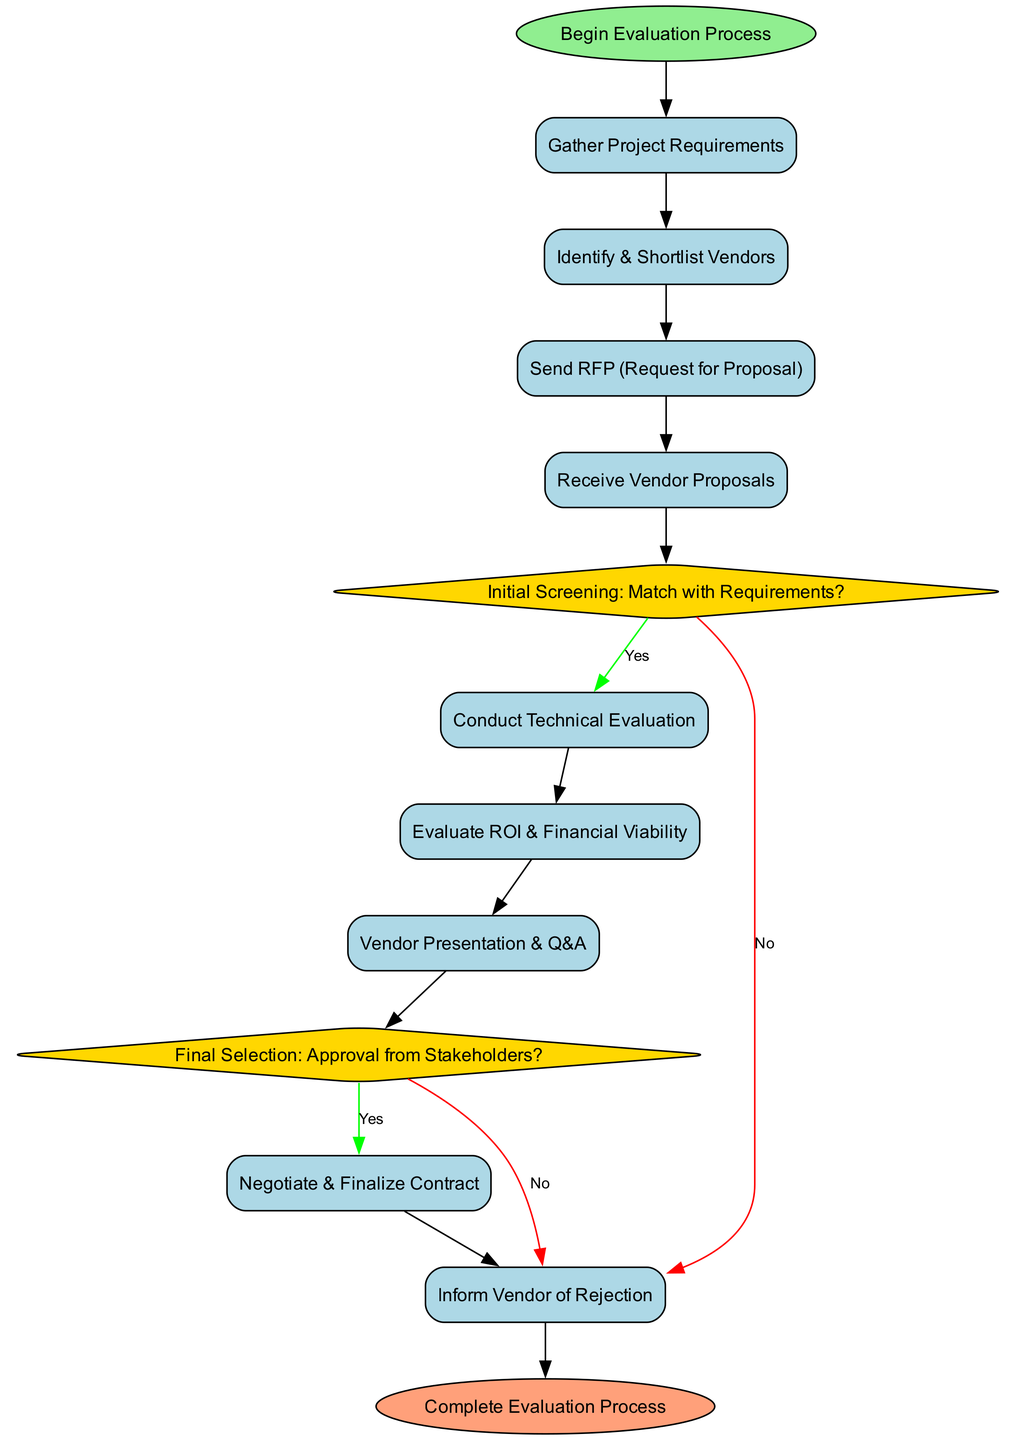What is the first step in the evaluation process? The diagram shows that the first node is labeled "Begin Evaluation Process," indicating that this is the initial step in the workflow.
Answer: Begin Evaluation Process How many decision points are present in the diagram? The diagram contains two decision nodes: "Initial Screening: Match with Requirements?" and "Final Selection: Approval from Stakeholders?" Therefore, there are two decision points.
Answer: 2 What follows after receiving vendor proposals? According to the flowchart, the step that directly follows "Receive Vendor Proposals" is "Initial Screening: Match with Requirements?"
Answer: Initial Screening: Match with Requirements? If the answer is "no" to the initial screening, what occurs next? In the flowchart, if the answer to "Initial Screening: Match with Requirements?" is "no," the next step is "Inform Vendor of Rejection." This process indicates the rejection of the vendor proposal.
Answer: Inform Vendor of Rejection What are the last two steps before completing the evaluation process? From the diagram, the last two processes before the "Complete Evaluation Process" are "Negotiate & Finalize Contract" and "Inform Vendor of Rejection." The last processes involve finalizing the vendor selection or informing them of rejection.
Answer: Negotiate & Finalize Contract, Inform Vendor of Rejection 